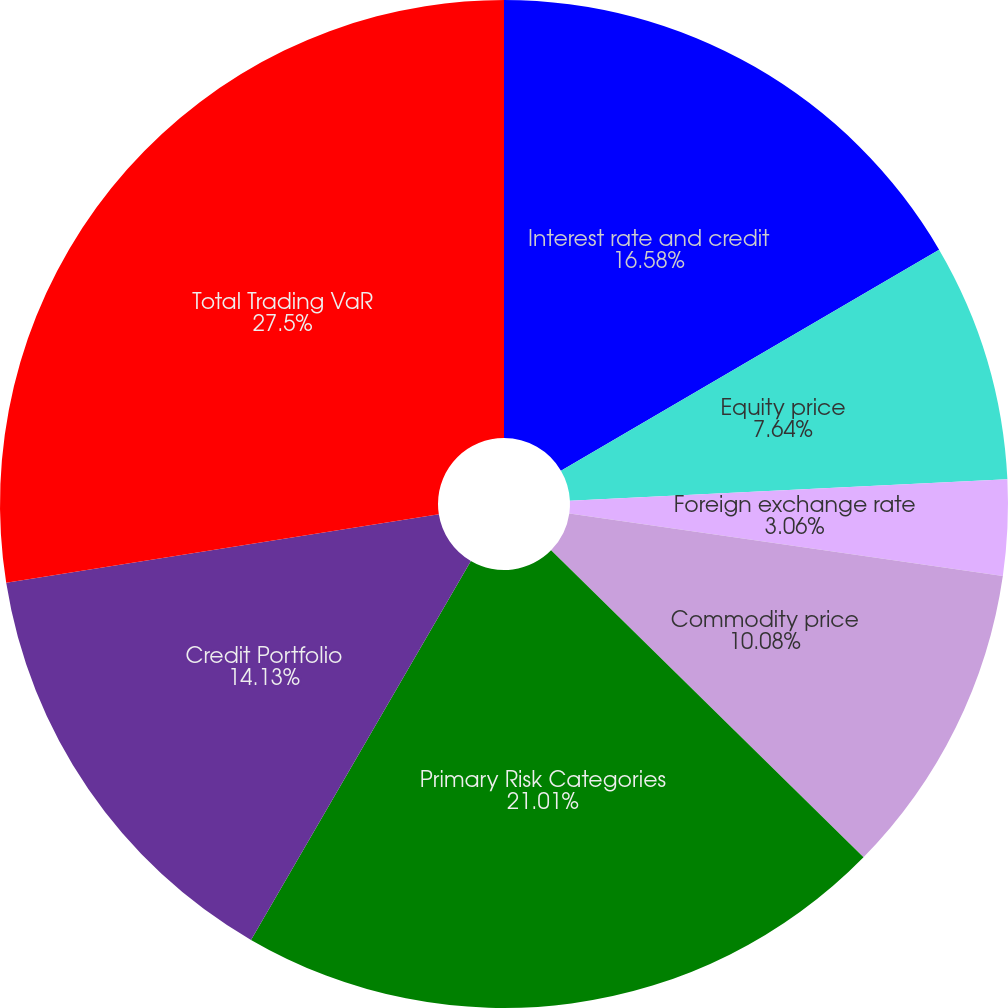<chart> <loc_0><loc_0><loc_500><loc_500><pie_chart><fcel>Interest rate and credit<fcel>Equity price<fcel>Foreign exchange rate<fcel>Commodity price<fcel>Primary Risk Categories<fcel>Credit Portfolio<fcel>Total Trading VaR<nl><fcel>16.58%<fcel>7.64%<fcel>3.06%<fcel>10.08%<fcel>21.01%<fcel>14.13%<fcel>27.5%<nl></chart> 